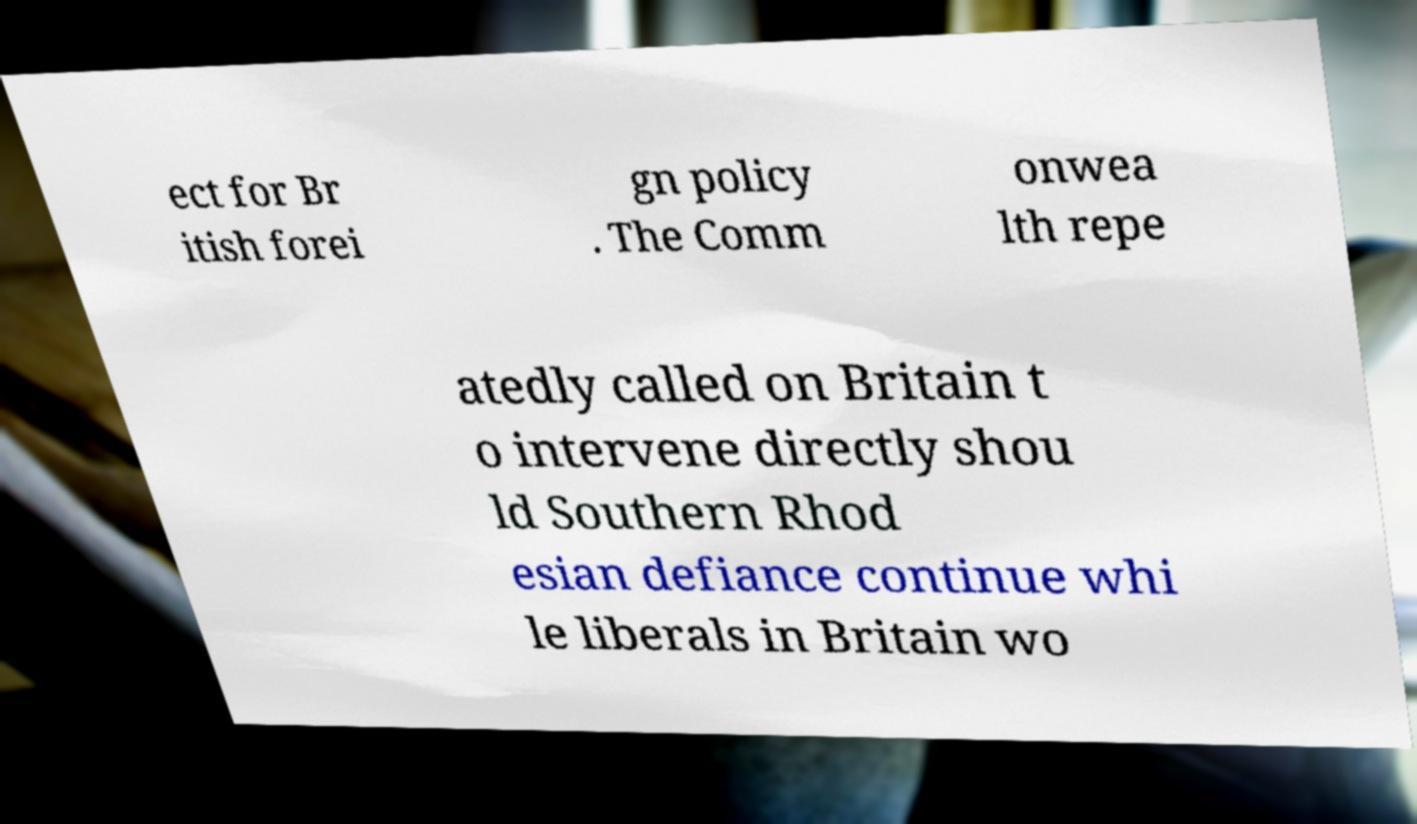Can you accurately transcribe the text from the provided image for me? ect for Br itish forei gn policy . The Comm onwea lth repe atedly called on Britain t o intervene directly shou ld Southern Rhod esian defiance continue whi le liberals in Britain wo 